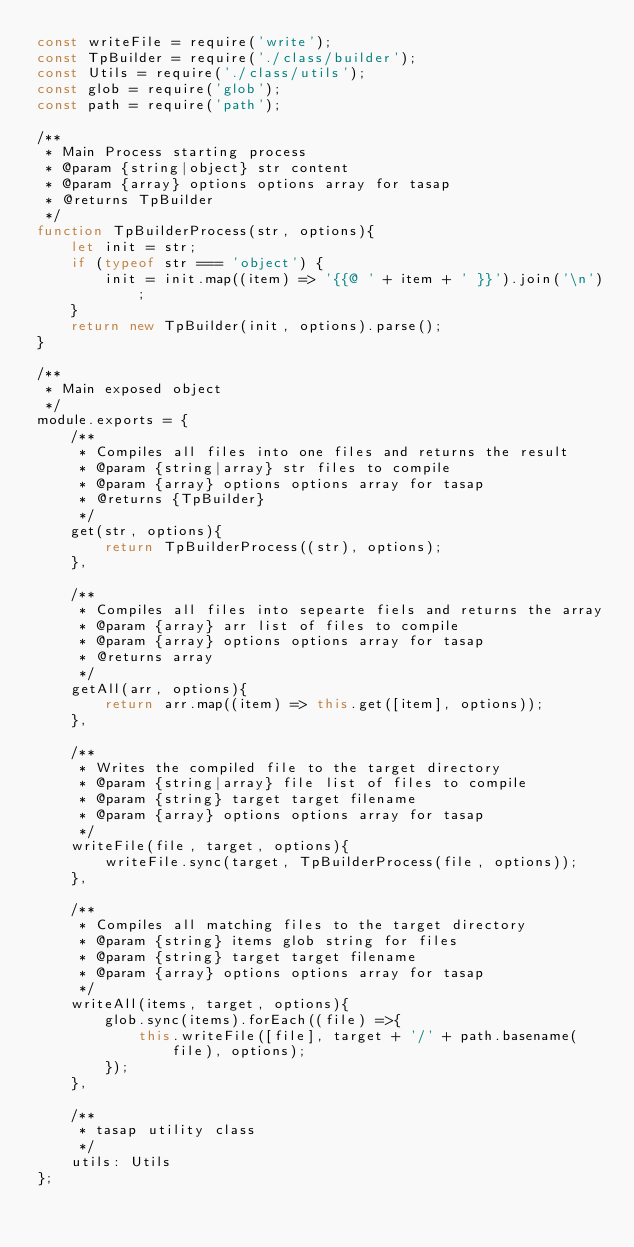Convert code to text. <code><loc_0><loc_0><loc_500><loc_500><_JavaScript_>const writeFile = require('write');
const TpBuilder = require('./class/builder');
const Utils = require('./class/utils');
const glob = require('glob');
const path = require('path');

/**
 * Main Process starting process
 * @param {string|object} str content
 * @param {array} options options array for tasap
 * @returns TpBuilder
 */
function TpBuilderProcess(str, options){
    let init = str;
    if (typeof str === 'object') {
        init = init.map((item) => '{{@ ' + item + ' }}').join('\n');
    }
    return new TpBuilder(init, options).parse();
}

/**
 * Main exposed object
 */
module.exports = {
    /**
     * Compiles all files into one files and returns the result
     * @param {string|array} str files to compile
     * @param {array} options options array for tasap
     * @returns {TpBuilder}
     */
    get(str, options){
        return TpBuilderProcess((str), options);
    },

    /**
     * Compiles all files into sepearte fiels and returns the array
     * @param {array} arr list of files to compile
     * @param {array} options options array for tasap
     * @returns array
     */
    getAll(arr, options){
        return arr.map((item) => this.get([item], options));
    },

    /**
     * Writes the compiled file to the target directory
     * @param {string|array} file list of files to compile
     * @param {string} target target filename
     * @param {array} options options array for tasap
     */
    writeFile(file, target, options){
        writeFile.sync(target, TpBuilderProcess(file, options));
    },

    /**
     * Compiles all matching files to the target directory
     * @param {string} items glob string for files
     * @param {string} target target filename
     * @param {array} options options array for tasap
     */
    writeAll(items, target, options){
        glob.sync(items).forEach((file) =>{
            this.writeFile([file], target + '/' + path.basename(file), options);
        });
    },

    /**
     * tasap utility class
     */
    utils: Utils
};</code> 